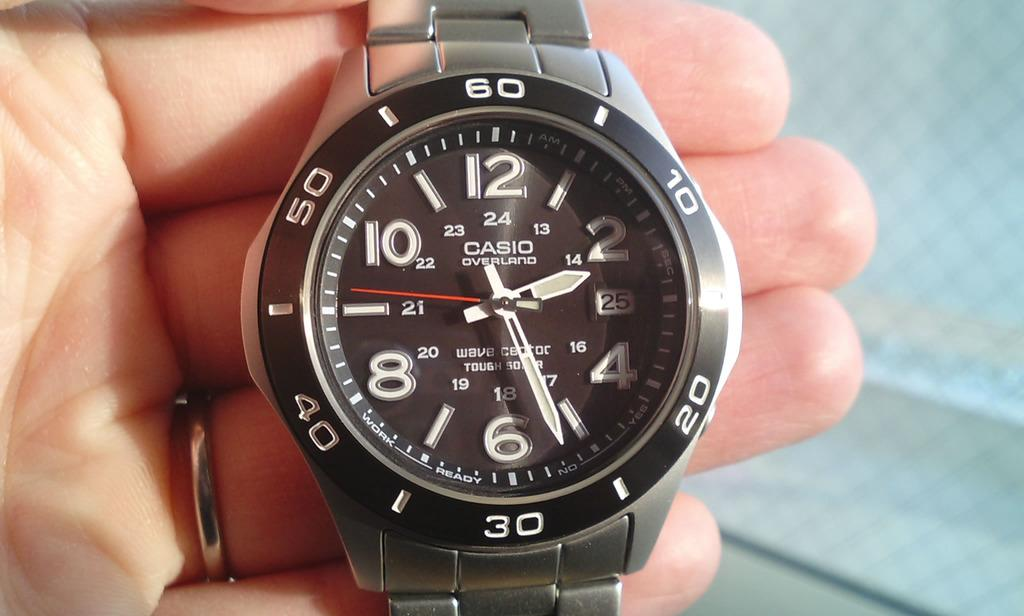<image>
Provide a brief description of the given image. The black watch is made by the company Casio 